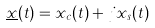Convert formula to latex. <formula><loc_0><loc_0><loc_500><loc_500>\underline { x } ( t ) = x _ { c } ( t ) + j x _ { s } ( t )</formula> 